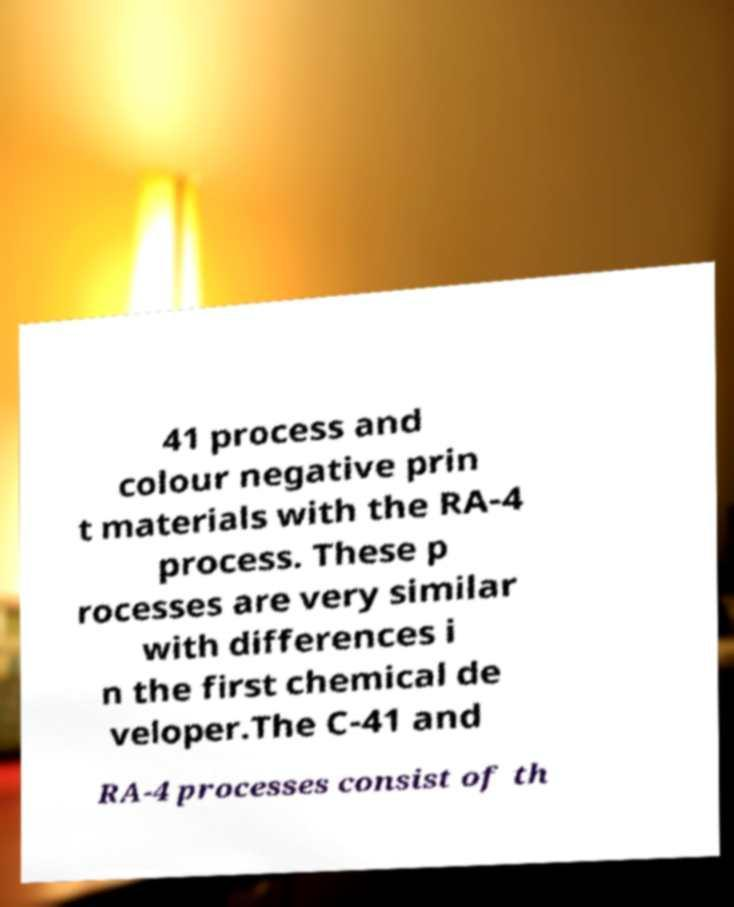Could you extract and type out the text from this image? 41 process and colour negative prin t materials with the RA-4 process. These p rocesses are very similar with differences i n the first chemical de veloper.The C-41 and RA-4 processes consist of th 